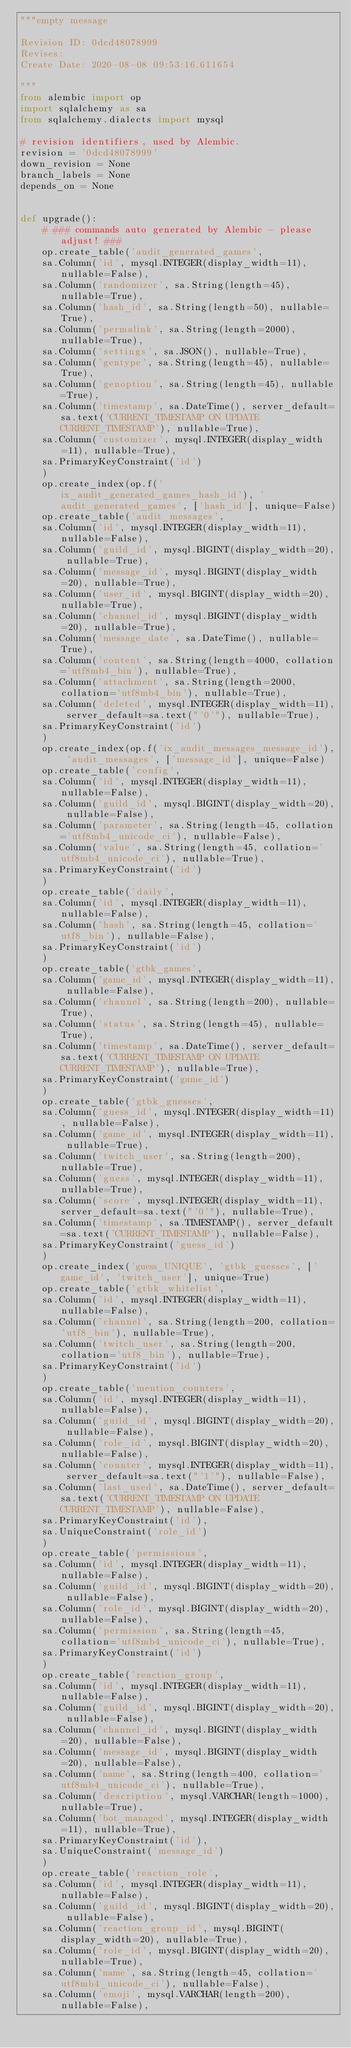<code> <loc_0><loc_0><loc_500><loc_500><_Python_>"""empty message

Revision ID: 0dcd48078999
Revises: 
Create Date: 2020-08-08 09:53:16.611654

"""
from alembic import op
import sqlalchemy as sa
from sqlalchemy.dialects import mysql

# revision identifiers, used by Alembic.
revision = '0dcd48078999'
down_revision = None
branch_labels = None
depends_on = None


def upgrade():
    # ### commands auto generated by Alembic - please adjust! ###
    op.create_table('audit_generated_games',
    sa.Column('id', mysql.INTEGER(display_width=11), nullable=False),
    sa.Column('randomizer', sa.String(length=45), nullable=True),
    sa.Column('hash_id', sa.String(length=50), nullable=True),
    sa.Column('permalink', sa.String(length=2000), nullable=True),
    sa.Column('settings', sa.JSON(), nullable=True),
    sa.Column('gentype', sa.String(length=45), nullable=True),
    sa.Column('genoption', sa.String(length=45), nullable=True),
    sa.Column('timestamp', sa.DateTime(), server_default=sa.text('CURRENT_TIMESTAMP ON UPDATE CURRENT_TIMESTAMP'), nullable=True),
    sa.Column('customizer', mysql.INTEGER(display_width=11), nullable=True),
    sa.PrimaryKeyConstraint('id')
    )
    op.create_index(op.f('ix_audit_generated_games_hash_id'), 'audit_generated_games', ['hash_id'], unique=False)
    op.create_table('audit_messages',
    sa.Column('id', mysql.INTEGER(display_width=11), nullable=False),
    sa.Column('guild_id', mysql.BIGINT(display_width=20), nullable=True),
    sa.Column('message_id', mysql.BIGINT(display_width=20), nullable=True),
    sa.Column('user_id', mysql.BIGINT(display_width=20), nullable=True),
    sa.Column('channel_id', mysql.BIGINT(display_width=20), nullable=True),
    sa.Column('message_date', sa.DateTime(), nullable=True),
    sa.Column('content', sa.String(length=4000, collation='utf8mb4_bin'), nullable=True),
    sa.Column('attachment', sa.String(length=2000, collation='utf8mb4_bin'), nullable=True),
    sa.Column('deleted', mysql.INTEGER(display_width=11), server_default=sa.text("'0'"), nullable=True),
    sa.PrimaryKeyConstraint('id')
    )
    op.create_index(op.f('ix_audit_messages_message_id'), 'audit_messages', ['message_id'], unique=False)
    op.create_table('config',
    sa.Column('id', mysql.INTEGER(display_width=11), nullable=False),
    sa.Column('guild_id', mysql.BIGINT(display_width=20), nullable=False),
    sa.Column('parameter', sa.String(length=45, collation='utf8mb4_unicode_ci'), nullable=False),
    sa.Column('value', sa.String(length=45, collation='utf8mb4_unicode_ci'), nullable=True),
    sa.PrimaryKeyConstraint('id')
    )
    op.create_table('daily',
    sa.Column('id', mysql.INTEGER(display_width=11), nullable=False),
    sa.Column('hash', sa.String(length=45, collation='utf8_bin'), nullable=False),
    sa.PrimaryKeyConstraint('id')
    )
    op.create_table('gtbk_games',
    sa.Column('game_id', mysql.INTEGER(display_width=11), nullable=False),
    sa.Column('channel', sa.String(length=200), nullable=True),
    sa.Column('status', sa.String(length=45), nullable=True),
    sa.Column('timestamp', sa.DateTime(), server_default=sa.text('CURRENT_TIMESTAMP ON UPDATE CURRENT_TIMESTAMP'), nullable=True),
    sa.PrimaryKeyConstraint('game_id')
    )
    op.create_table('gtbk_guesses',
    sa.Column('guess_id', mysql.INTEGER(display_width=11), nullable=False),
    sa.Column('game_id', mysql.INTEGER(display_width=11), nullable=True),
    sa.Column('twitch_user', sa.String(length=200), nullable=True),
    sa.Column('guess', mysql.INTEGER(display_width=11), nullable=True),
    sa.Column('score', mysql.INTEGER(display_width=11), server_default=sa.text("'0'"), nullable=True),
    sa.Column('timestamp', sa.TIMESTAMP(), server_default=sa.text('CURRENT_TIMESTAMP'), nullable=False),
    sa.PrimaryKeyConstraint('guess_id')
    )
    op.create_index('guess_UNIQUE', 'gtbk_guesses', ['game_id', 'twitch_user'], unique=True)
    op.create_table('gtbk_whitelist',
    sa.Column('id', mysql.INTEGER(display_width=11), nullable=False),
    sa.Column('channel', sa.String(length=200, collation='utf8_bin'), nullable=True),
    sa.Column('twitch_user', sa.String(length=200, collation='utf8_bin'), nullable=True),
    sa.PrimaryKeyConstraint('id')
    )
    op.create_table('mention_counters',
    sa.Column('id', mysql.INTEGER(display_width=11), nullable=False),
    sa.Column('guild_id', mysql.BIGINT(display_width=20), nullable=False),
    sa.Column('role_id', mysql.BIGINT(display_width=20), nullable=False),
    sa.Column('counter', mysql.INTEGER(display_width=11), server_default=sa.text("'1'"), nullable=False),
    sa.Column('last_used', sa.DateTime(), server_default=sa.text('CURRENT_TIMESTAMP ON UPDATE CURRENT_TIMESTAMP'), nullable=False),
    sa.PrimaryKeyConstraint('id'),
    sa.UniqueConstraint('role_id')
    )
    op.create_table('permissions',
    sa.Column('id', mysql.INTEGER(display_width=11), nullable=False),
    sa.Column('guild_id', mysql.BIGINT(display_width=20), nullable=False),
    sa.Column('role_id', mysql.BIGINT(display_width=20), nullable=False),
    sa.Column('permission', sa.String(length=45, collation='utf8mb4_unicode_ci'), nullable=True),
    sa.PrimaryKeyConstraint('id')
    )
    op.create_table('reaction_group',
    sa.Column('id', mysql.INTEGER(display_width=11), nullable=False),
    sa.Column('guild_id', mysql.BIGINT(display_width=20), nullable=False),
    sa.Column('channel_id', mysql.BIGINT(display_width=20), nullable=False),
    sa.Column('message_id', mysql.BIGINT(display_width=20), nullable=False),
    sa.Column('name', sa.String(length=400, collation='utf8mb4_unicode_ci'), nullable=True),
    sa.Column('description', mysql.VARCHAR(length=1000), nullable=True),
    sa.Column('bot_managed', mysql.INTEGER(display_width=11), nullable=True),
    sa.PrimaryKeyConstraint('id'),
    sa.UniqueConstraint('message_id')
    )
    op.create_table('reaction_role',
    sa.Column('id', mysql.INTEGER(display_width=11), nullable=False),
    sa.Column('guild_id', mysql.BIGINT(display_width=20), nullable=False),
    sa.Column('reaction_group_id', mysql.BIGINT(display_width=20), nullable=True),
    sa.Column('role_id', mysql.BIGINT(display_width=20), nullable=True),
    sa.Column('name', sa.String(length=45, collation='utf8mb4_unicode_ci'), nullable=False),
    sa.Column('emoji', mysql.VARCHAR(length=200), nullable=False),</code> 